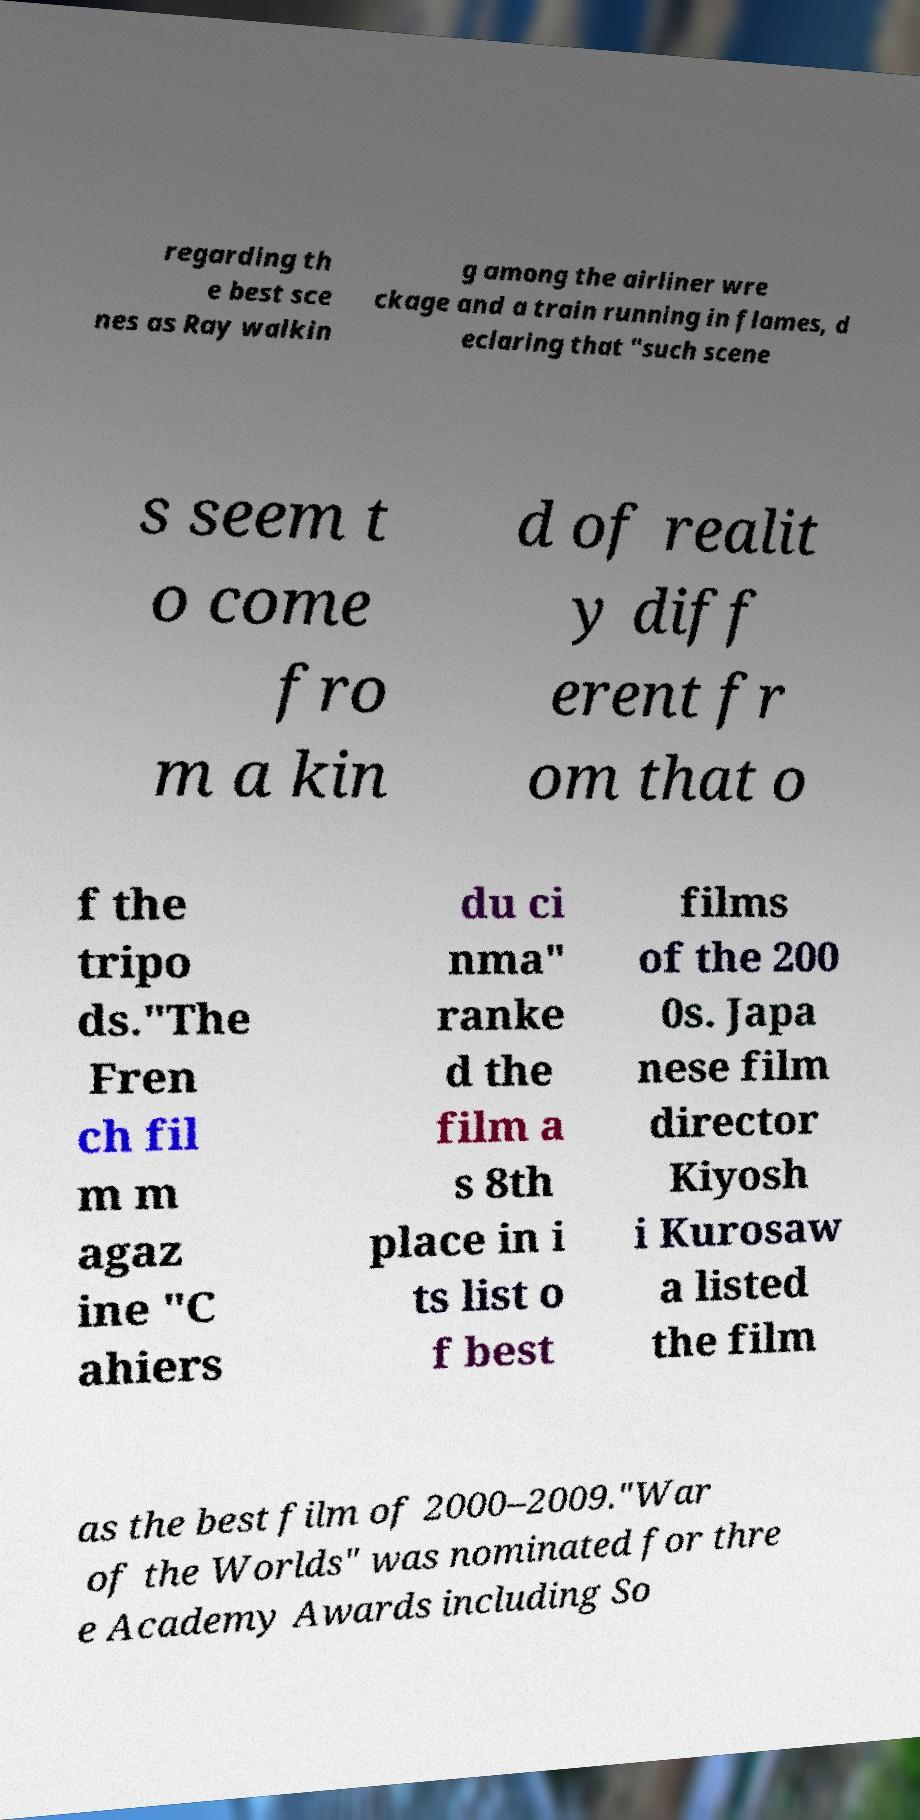Can you accurately transcribe the text from the provided image for me? regarding th e best sce nes as Ray walkin g among the airliner wre ckage and a train running in flames, d eclaring that "such scene s seem t o come fro m a kin d of realit y diff erent fr om that o f the tripo ds."The Fren ch fil m m agaz ine "C ahiers du ci nma" ranke d the film a s 8th place in i ts list o f best films of the 200 0s. Japa nese film director Kiyosh i Kurosaw a listed the film as the best film of 2000–2009."War of the Worlds" was nominated for thre e Academy Awards including So 